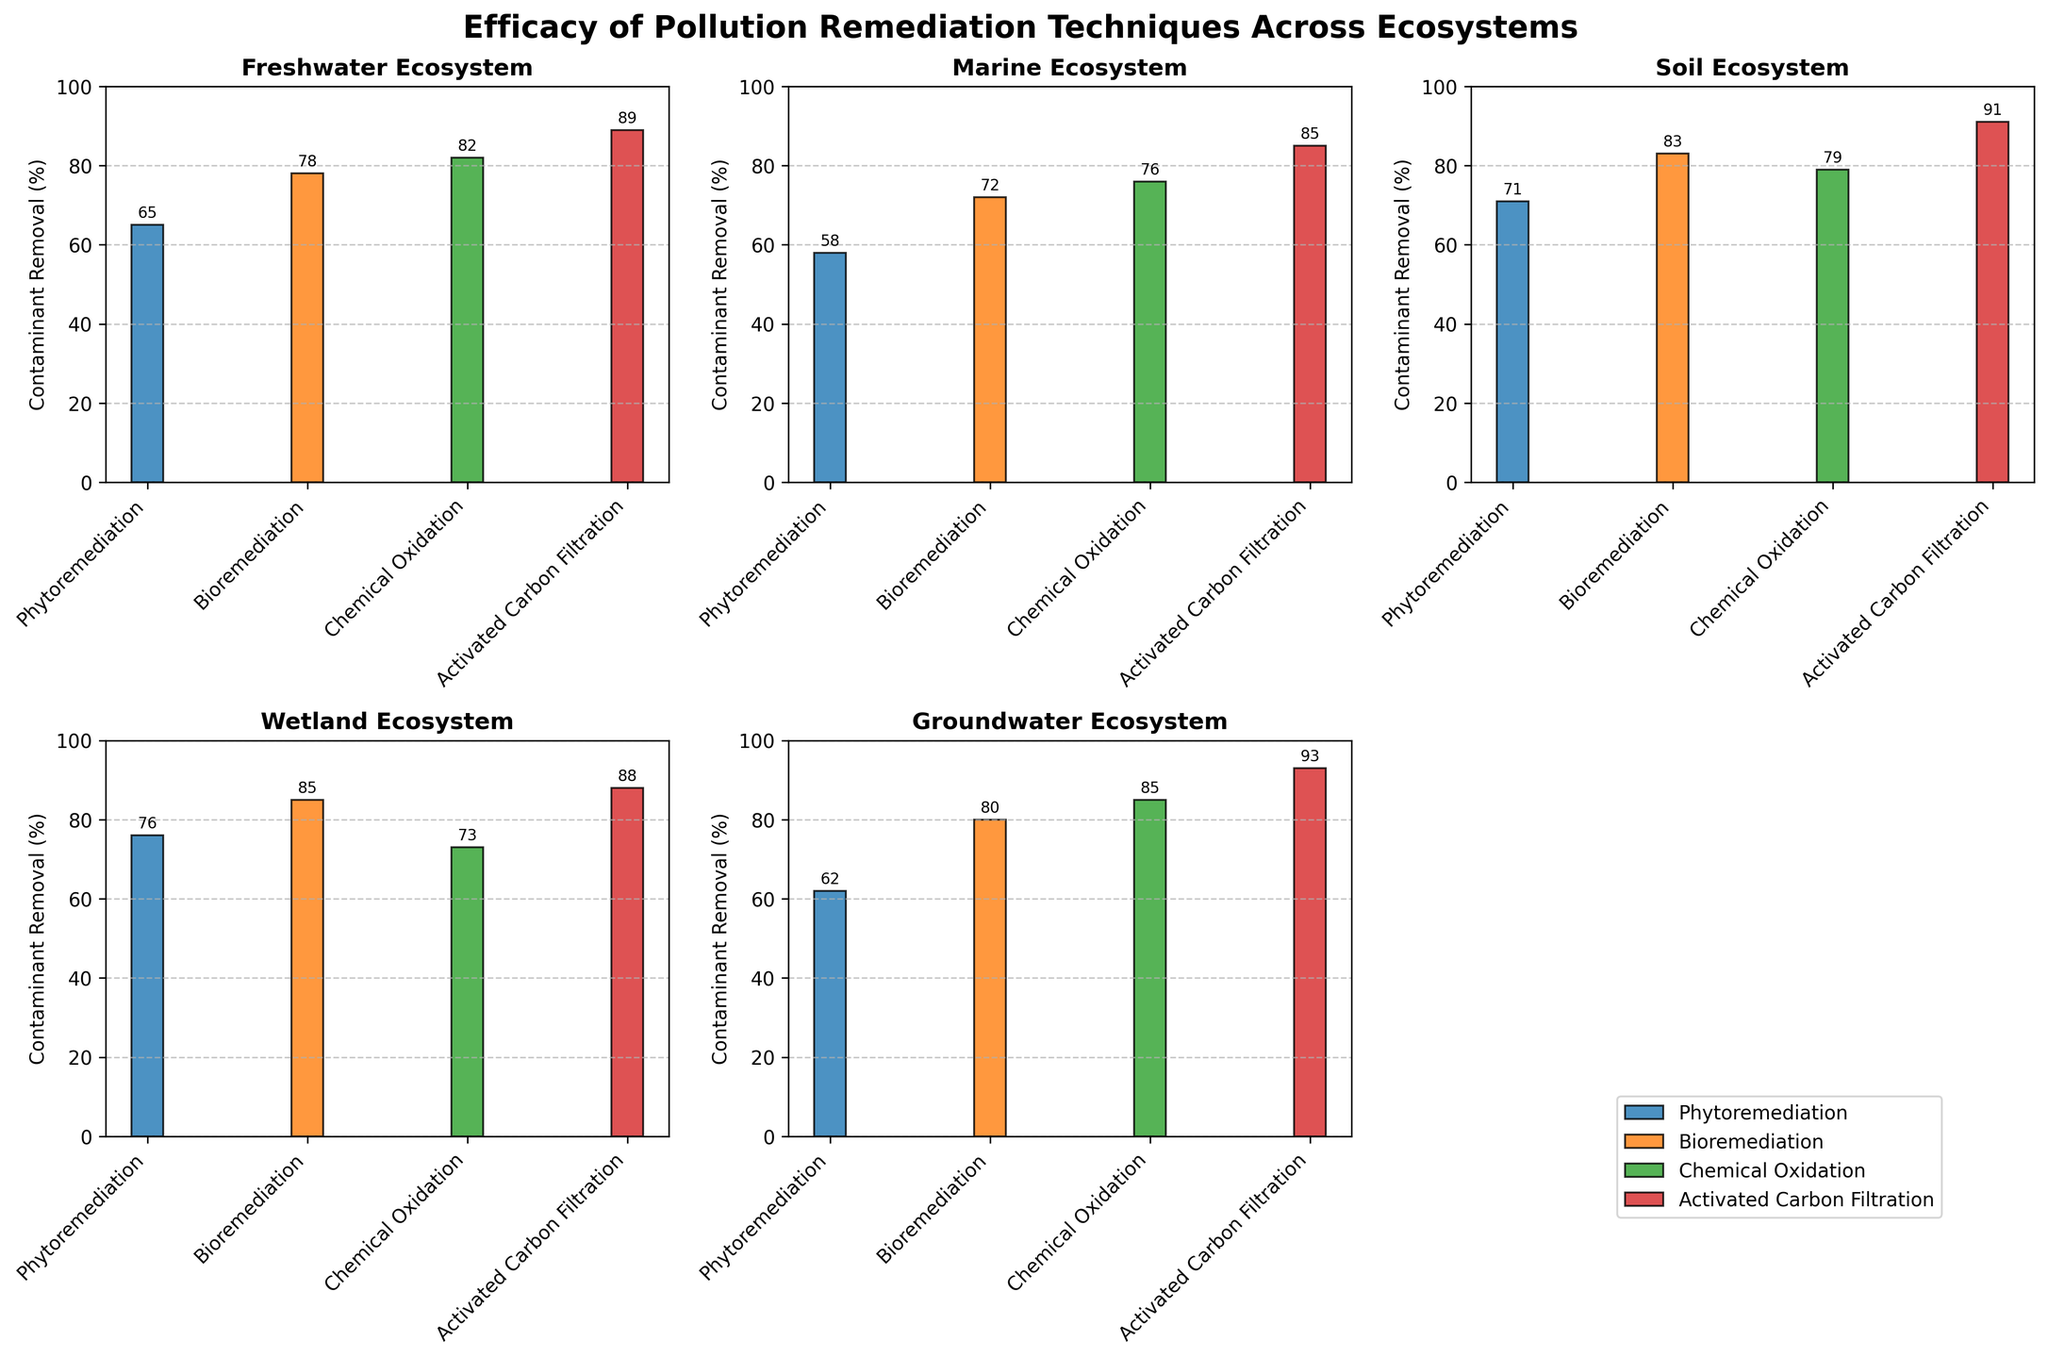Which ecosystem shows the highest average contaminant removal percentage? To determine this, calculate the average contaminant removal percentage for each ecosystem. Freshwater: (65 + 78 + 82 + 89) / 4 = 78.5; Marine: (58 + 72 + 76 + 85) / 4 = 72.75; Soil: (71 + 83 + 79 + 91) / 4 = 81; Wetland: (76 + 85 + 73 + 88) / 4 = 80.5; Groundwater: (62 + 80 + 85 + 93) / 4 = 80. The highest average is Soil with 81%.
Answer: Soil Which technique has the highest single contaminant removal percentage across all ecosystems? Identify the highest contaminant removal percentage in the plots across all techniques and ecosystems. The highest value is for Activated Carbon Filtration in Groundwater with 93%.
Answer: Activated Carbon Filtration in Groundwater How does the efficacy of Phytoremediation compare between Freshwater and Marine ecosystems? Compare the contaminant removal percentages of Phytoremediation in Freshwater (65%) and Marine (58%). Freshwater has a higher percentage (65%) compared to Marine (58%).
Answer: Freshwater 65%, Marine 58% Which ecosystem has the lowest efficacy for Chemical Oxidation? Compare the contaminant removal percentages of Chemical Oxidation across all ecosystems. Freshwater: 82%, Marine: 76%, Soil: 79%, Wetland: 73%, Groundwater: 85%. The Wetland ecosystem has the lowest at 73%.
Answer: Wetland What is the average contaminant removal percentage for Bioremediation across all ecosystems? Calculate the contaminant removal percentage for Bioremediation in each ecosystem and find the average: Freshwater (78), Marine (72), Soil (83), Wetland (85), Groundwater (80). (78 + 72 + 83 + 85 + 80) / 5 = 79.6%
Answer: 79.6% In which ecosystem does Activated Carbon Filtration show the greatest efficacy? Compare the contaminant removal percentages of Activated Carbon Filtration across all ecosystems. Freshwater: 89%, Marine: 85%, Soil: 91%, Wetland: 88%, Groundwater: 93%. The highest value is in Groundwater with 93%.
Answer: Groundwater What is the difference in contaminant removal percentage for Phytoremediation between Wetland and Soil ecosystems? Calculate the difference: Wetland (76) and Soil (71). 76 - 71 = 5%.
Answer: 5% How do the contaminant removal percentages for Chemical Oxidation in Soil and Groundwater compare? Compare the values for Soil (79) and Groundwater (85). Groundwater has a higher percentage compared to Soil.
Answer: Groundwater 85%, Soil 79% Which ecosystem and technique combination yields the lowest contaminant removal percentage? Identify the lowest value across all combination plots. The lowest value is for Phytoremediation in Marine ecosystems with 58%.
Answer: Phytoremediation in Marine 